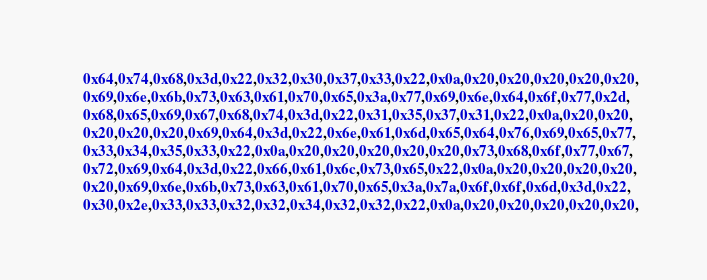Convert code to text. <code><loc_0><loc_0><loc_500><loc_500><_C_>    0x64,0x74,0x68,0x3d,0x22,0x32,0x30,0x37,0x33,0x22,0x0a,0x20,0x20,0x20,0x20,0x20,
    0x69,0x6e,0x6b,0x73,0x63,0x61,0x70,0x65,0x3a,0x77,0x69,0x6e,0x64,0x6f,0x77,0x2d,
    0x68,0x65,0x69,0x67,0x68,0x74,0x3d,0x22,0x31,0x35,0x37,0x31,0x22,0x0a,0x20,0x20,
    0x20,0x20,0x20,0x69,0x64,0x3d,0x22,0x6e,0x61,0x6d,0x65,0x64,0x76,0x69,0x65,0x77,
    0x33,0x34,0x35,0x33,0x22,0x0a,0x20,0x20,0x20,0x20,0x20,0x73,0x68,0x6f,0x77,0x67,
    0x72,0x69,0x64,0x3d,0x22,0x66,0x61,0x6c,0x73,0x65,0x22,0x0a,0x20,0x20,0x20,0x20,
    0x20,0x69,0x6e,0x6b,0x73,0x63,0x61,0x70,0x65,0x3a,0x7a,0x6f,0x6f,0x6d,0x3d,0x22,
    0x30,0x2e,0x33,0x33,0x32,0x32,0x34,0x32,0x32,0x22,0x0a,0x20,0x20,0x20,0x20,0x20,</code> 